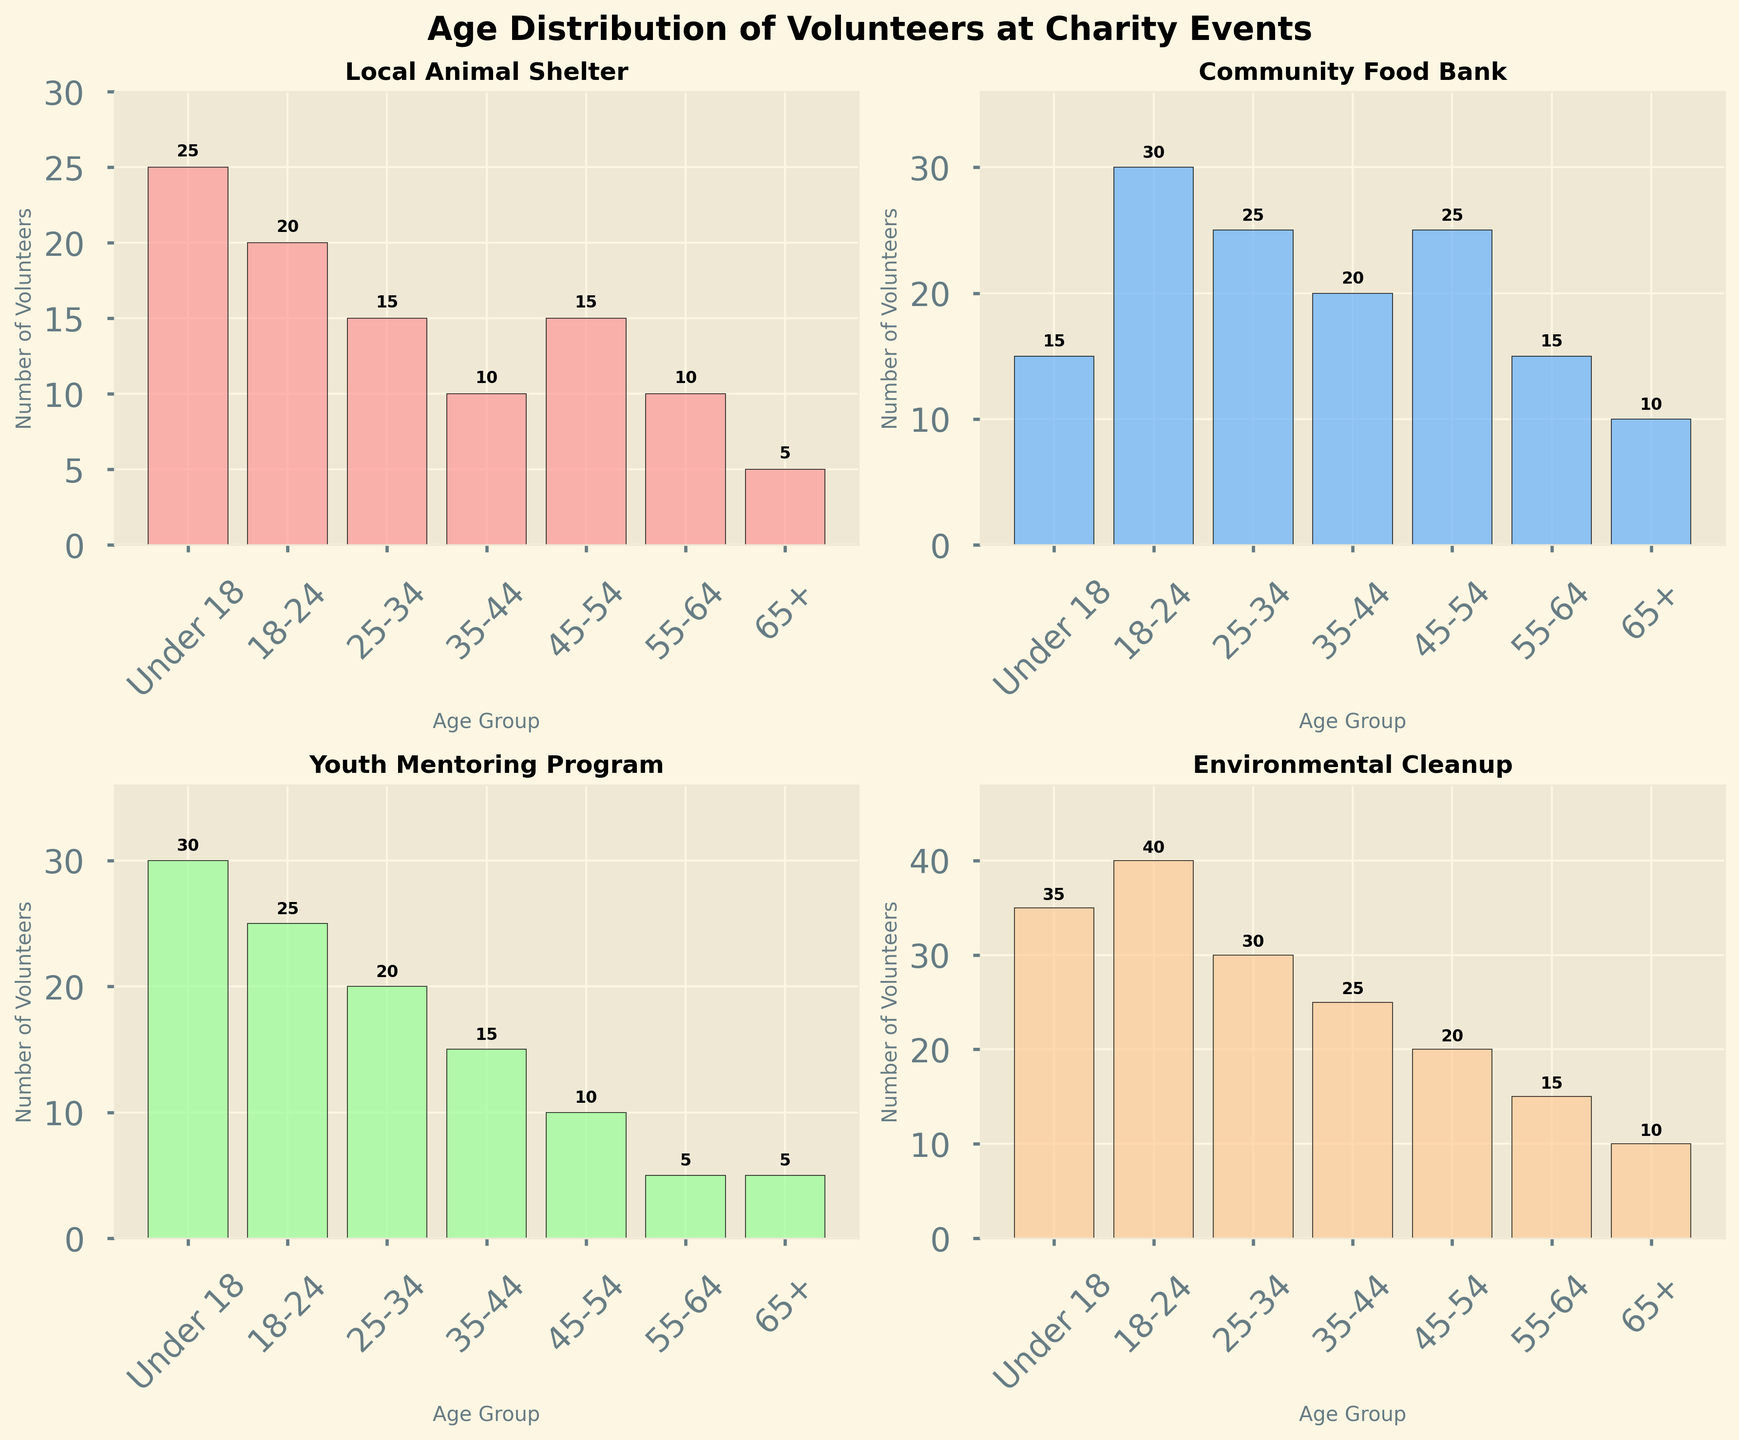What's the title of the figure? The title of the figure is displayed prominently at the top of the plot.
Answer: Age Distribution of Volunteers at Charity Events How many age groups are shown in each subplot? Each subplot shows the same set of age groups listed on the x-axis.
Answer: 7 Which charity event has the highest number of volunteers in the '18-24' age group? By looking at the '18-24' age group across all subplots, we can compare the heights of the bars. The 'Environmental Cleanup' event has the highest bar for the '18-24' age group.
Answer: Environmental Cleanup Which age group has the least number of volunteers in the Youth Mentoring Program? By examining the bars for the 'Youth Mentoring Program' subplot, we can identify the shortest bar. The '65+' age group has the smallest bar.
Answer: 65+ What is the total number of volunteers in the '55-64' age group across all events? Sum the bar heights for the '55-64' age group across all subplots: 10 (Local Animal Shelter) + 15 (Community Food Bank) + 5 (Youth Mentoring Program) + 15 (Environmental Cleanup).
Answer: 45 Which age group contributes the highest number of volunteers to the Local Animal Shelter? In the 'Local Animal Shelter' subplot, the height of the bars determines the number of volunteers. The 'Under 18' age group has the tallest bar.
Answer: Under 18 What is the combined total number of volunteers from the '35-44' and '45-54' age groups in the Environmental Cleanup event? Add the heights of the bars for the '35-44' and '45-54' age groups in the 'Environmental Cleanup' subplot: 25 (35-44) + 20 (45-54).
Answer: 45 How does the number of volunteers aged '25-34' compare between the Community Food Bank and the Youth Mentoring Program? Compare the heights of the bars for the '25-34' age group in both respective subplots. The 'Community Food Bank' has more volunteers (25) than the 'Youth Mentoring Program' (20).
Answer: Community Food Bank has more In which charity event is the distribution of volunteers the most uniform across different age groups? To determine uniformity, observe the heights of the bars in each subplot. The 'Community Food Bank' subplot shows relatively even bar heights, indicating a more uniform distribution.
Answer: Community Food Bank 